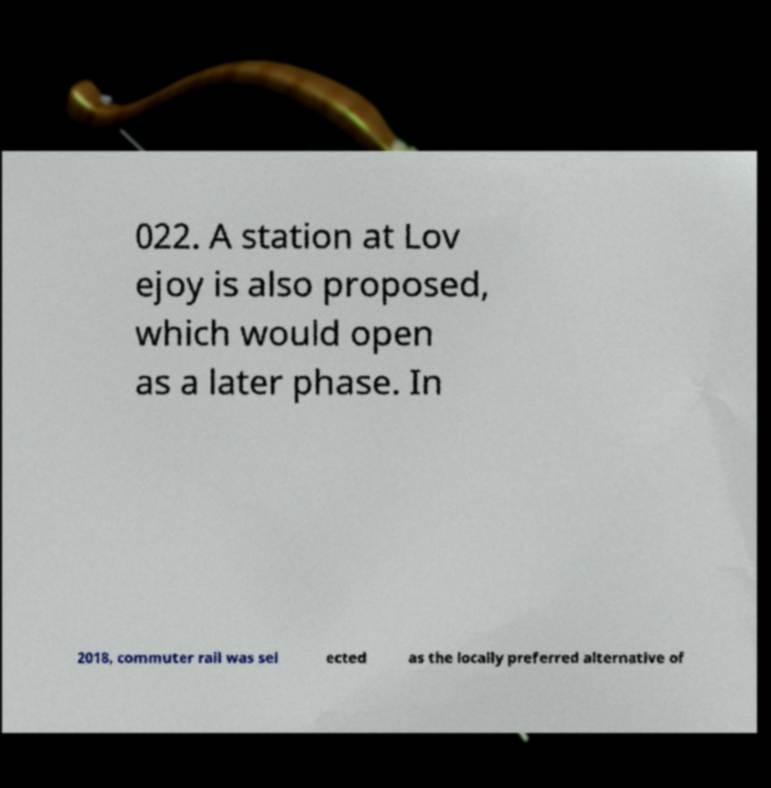For documentation purposes, I need the text within this image transcribed. Could you provide that? 022. A station at Lov ejoy is also proposed, which would open as a later phase. In 2018, commuter rail was sel ected as the locally preferred alternative of 